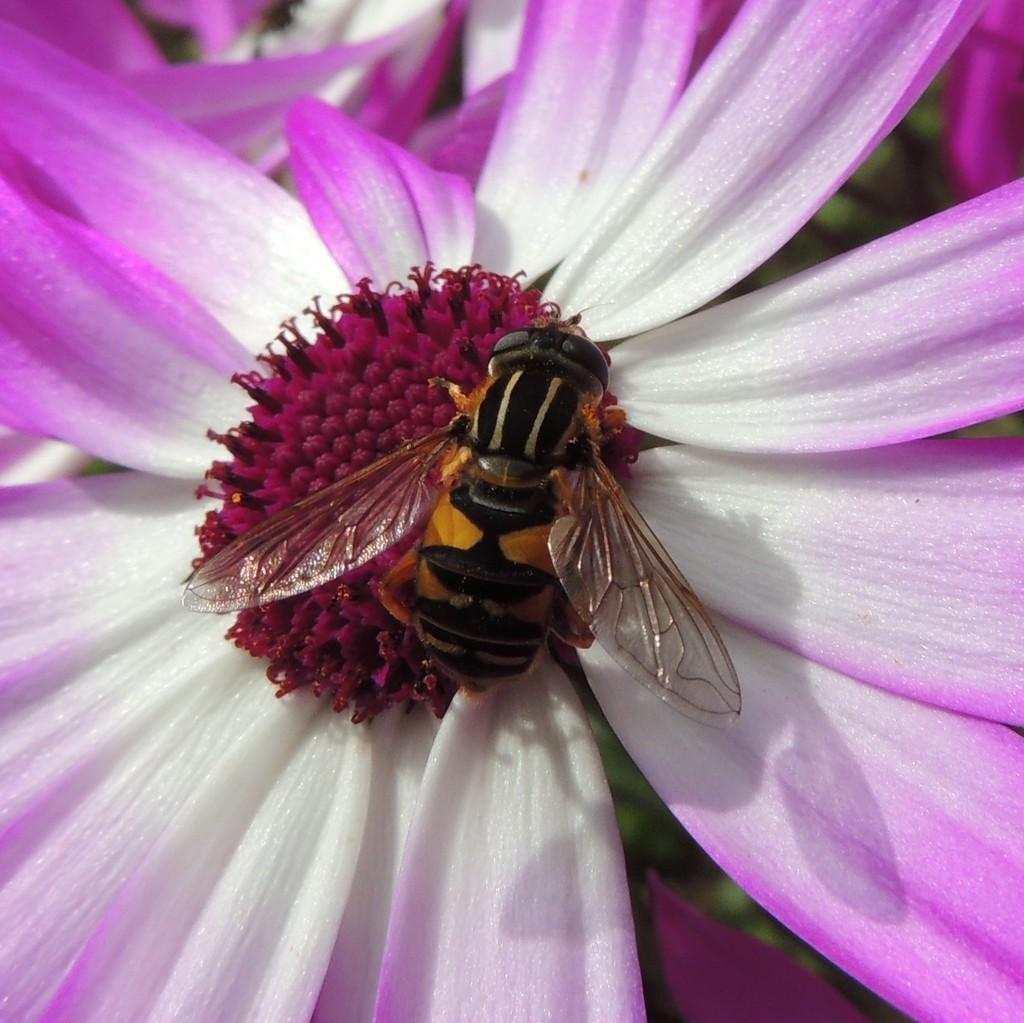Please provide a concise description of this image. In this picture, we can see an ant which is on the flower. In the background, we can see green color. 